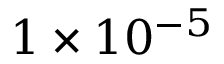<formula> <loc_0><loc_0><loc_500><loc_500>1 \times 1 0 ^ { - 5 }</formula> 